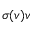Convert formula to latex. <formula><loc_0><loc_0><loc_500><loc_500>\sigma ( v ) v</formula> 